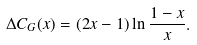<formula> <loc_0><loc_0><loc_500><loc_500>\Delta C _ { G } ( x ) = ( 2 x - 1 ) \ln { \frac { 1 - x } { x } } .</formula> 